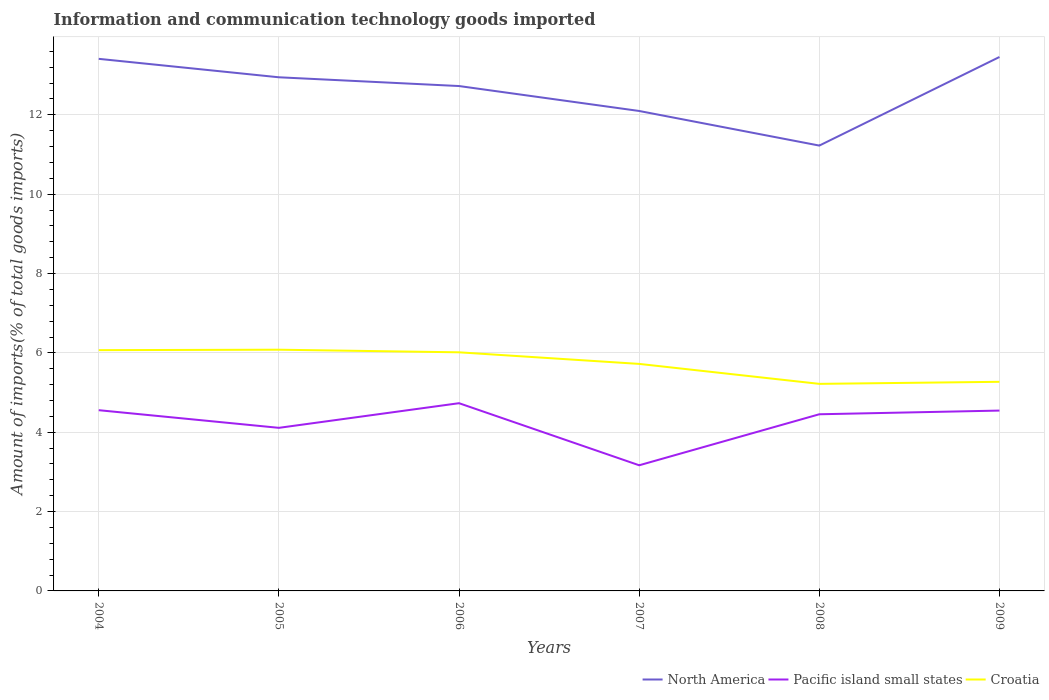How many different coloured lines are there?
Give a very brief answer. 3. Does the line corresponding to Croatia intersect with the line corresponding to North America?
Your response must be concise. No. Across all years, what is the maximum amount of goods imported in Pacific island small states?
Provide a succinct answer. 3.17. What is the total amount of goods imported in North America in the graph?
Your answer should be very brief. 1.31. What is the difference between the highest and the second highest amount of goods imported in Pacific island small states?
Make the answer very short. 1.57. What is the difference between the highest and the lowest amount of goods imported in Pacific island small states?
Offer a terse response. 4. Is the amount of goods imported in North America strictly greater than the amount of goods imported in Pacific island small states over the years?
Give a very brief answer. No. How many years are there in the graph?
Ensure brevity in your answer.  6. Does the graph contain any zero values?
Provide a succinct answer. No. Does the graph contain grids?
Ensure brevity in your answer.  Yes. What is the title of the graph?
Make the answer very short. Information and communication technology goods imported. What is the label or title of the Y-axis?
Keep it short and to the point. Amount of imports(% of total goods imports). What is the Amount of imports(% of total goods imports) in North America in 2004?
Provide a short and direct response. 13.41. What is the Amount of imports(% of total goods imports) of Pacific island small states in 2004?
Provide a short and direct response. 4.56. What is the Amount of imports(% of total goods imports) of Croatia in 2004?
Your response must be concise. 6.07. What is the Amount of imports(% of total goods imports) in North America in 2005?
Offer a very short reply. 12.95. What is the Amount of imports(% of total goods imports) of Pacific island small states in 2005?
Your answer should be compact. 4.11. What is the Amount of imports(% of total goods imports) in Croatia in 2005?
Your answer should be very brief. 6.08. What is the Amount of imports(% of total goods imports) of North America in 2006?
Your answer should be very brief. 12.73. What is the Amount of imports(% of total goods imports) in Pacific island small states in 2006?
Your response must be concise. 4.73. What is the Amount of imports(% of total goods imports) of Croatia in 2006?
Keep it short and to the point. 6.01. What is the Amount of imports(% of total goods imports) in North America in 2007?
Your answer should be very brief. 12.1. What is the Amount of imports(% of total goods imports) in Pacific island small states in 2007?
Your answer should be compact. 3.17. What is the Amount of imports(% of total goods imports) of Croatia in 2007?
Keep it short and to the point. 5.72. What is the Amount of imports(% of total goods imports) of North America in 2008?
Your response must be concise. 11.23. What is the Amount of imports(% of total goods imports) of Pacific island small states in 2008?
Ensure brevity in your answer.  4.45. What is the Amount of imports(% of total goods imports) of Croatia in 2008?
Your answer should be very brief. 5.22. What is the Amount of imports(% of total goods imports) in North America in 2009?
Ensure brevity in your answer.  13.46. What is the Amount of imports(% of total goods imports) of Pacific island small states in 2009?
Your answer should be compact. 4.55. What is the Amount of imports(% of total goods imports) of Croatia in 2009?
Make the answer very short. 5.27. Across all years, what is the maximum Amount of imports(% of total goods imports) of North America?
Your response must be concise. 13.46. Across all years, what is the maximum Amount of imports(% of total goods imports) of Pacific island small states?
Make the answer very short. 4.73. Across all years, what is the maximum Amount of imports(% of total goods imports) of Croatia?
Keep it short and to the point. 6.08. Across all years, what is the minimum Amount of imports(% of total goods imports) in North America?
Offer a terse response. 11.23. Across all years, what is the minimum Amount of imports(% of total goods imports) in Pacific island small states?
Provide a succinct answer. 3.17. Across all years, what is the minimum Amount of imports(% of total goods imports) in Croatia?
Your response must be concise. 5.22. What is the total Amount of imports(% of total goods imports) in North America in the graph?
Your answer should be very brief. 75.87. What is the total Amount of imports(% of total goods imports) of Pacific island small states in the graph?
Make the answer very short. 25.56. What is the total Amount of imports(% of total goods imports) in Croatia in the graph?
Give a very brief answer. 34.38. What is the difference between the Amount of imports(% of total goods imports) of North America in 2004 and that in 2005?
Keep it short and to the point. 0.46. What is the difference between the Amount of imports(% of total goods imports) of Pacific island small states in 2004 and that in 2005?
Give a very brief answer. 0.44. What is the difference between the Amount of imports(% of total goods imports) of Croatia in 2004 and that in 2005?
Give a very brief answer. -0.01. What is the difference between the Amount of imports(% of total goods imports) in North America in 2004 and that in 2006?
Your answer should be very brief. 0.69. What is the difference between the Amount of imports(% of total goods imports) of Pacific island small states in 2004 and that in 2006?
Make the answer very short. -0.18. What is the difference between the Amount of imports(% of total goods imports) in Croatia in 2004 and that in 2006?
Your answer should be very brief. 0.05. What is the difference between the Amount of imports(% of total goods imports) of North America in 2004 and that in 2007?
Your answer should be very brief. 1.31. What is the difference between the Amount of imports(% of total goods imports) in Pacific island small states in 2004 and that in 2007?
Keep it short and to the point. 1.39. What is the difference between the Amount of imports(% of total goods imports) of Croatia in 2004 and that in 2007?
Offer a terse response. 0.35. What is the difference between the Amount of imports(% of total goods imports) in North America in 2004 and that in 2008?
Your answer should be very brief. 2.19. What is the difference between the Amount of imports(% of total goods imports) in Pacific island small states in 2004 and that in 2008?
Offer a terse response. 0.1. What is the difference between the Amount of imports(% of total goods imports) in Croatia in 2004 and that in 2008?
Your answer should be very brief. 0.85. What is the difference between the Amount of imports(% of total goods imports) of North America in 2004 and that in 2009?
Offer a very short reply. -0.05. What is the difference between the Amount of imports(% of total goods imports) in Pacific island small states in 2004 and that in 2009?
Ensure brevity in your answer.  0.01. What is the difference between the Amount of imports(% of total goods imports) in Croatia in 2004 and that in 2009?
Make the answer very short. 0.8. What is the difference between the Amount of imports(% of total goods imports) in North America in 2005 and that in 2006?
Ensure brevity in your answer.  0.22. What is the difference between the Amount of imports(% of total goods imports) in Pacific island small states in 2005 and that in 2006?
Your answer should be very brief. -0.62. What is the difference between the Amount of imports(% of total goods imports) in Croatia in 2005 and that in 2006?
Give a very brief answer. 0.07. What is the difference between the Amount of imports(% of total goods imports) in North America in 2005 and that in 2007?
Your answer should be compact. 0.85. What is the difference between the Amount of imports(% of total goods imports) in Pacific island small states in 2005 and that in 2007?
Keep it short and to the point. 0.94. What is the difference between the Amount of imports(% of total goods imports) of Croatia in 2005 and that in 2007?
Your answer should be compact. 0.36. What is the difference between the Amount of imports(% of total goods imports) in North America in 2005 and that in 2008?
Provide a short and direct response. 1.72. What is the difference between the Amount of imports(% of total goods imports) of Pacific island small states in 2005 and that in 2008?
Provide a succinct answer. -0.34. What is the difference between the Amount of imports(% of total goods imports) of Croatia in 2005 and that in 2008?
Provide a succinct answer. 0.86. What is the difference between the Amount of imports(% of total goods imports) in North America in 2005 and that in 2009?
Ensure brevity in your answer.  -0.51. What is the difference between the Amount of imports(% of total goods imports) in Pacific island small states in 2005 and that in 2009?
Provide a succinct answer. -0.43. What is the difference between the Amount of imports(% of total goods imports) in Croatia in 2005 and that in 2009?
Keep it short and to the point. 0.81. What is the difference between the Amount of imports(% of total goods imports) in North America in 2006 and that in 2007?
Ensure brevity in your answer.  0.63. What is the difference between the Amount of imports(% of total goods imports) of Pacific island small states in 2006 and that in 2007?
Give a very brief answer. 1.57. What is the difference between the Amount of imports(% of total goods imports) in Croatia in 2006 and that in 2007?
Ensure brevity in your answer.  0.29. What is the difference between the Amount of imports(% of total goods imports) of North America in 2006 and that in 2008?
Your answer should be compact. 1.5. What is the difference between the Amount of imports(% of total goods imports) of Pacific island small states in 2006 and that in 2008?
Give a very brief answer. 0.28. What is the difference between the Amount of imports(% of total goods imports) in Croatia in 2006 and that in 2008?
Ensure brevity in your answer.  0.8. What is the difference between the Amount of imports(% of total goods imports) in North America in 2006 and that in 2009?
Offer a terse response. -0.73. What is the difference between the Amount of imports(% of total goods imports) in Pacific island small states in 2006 and that in 2009?
Ensure brevity in your answer.  0.19. What is the difference between the Amount of imports(% of total goods imports) in Croatia in 2006 and that in 2009?
Your answer should be very brief. 0.74. What is the difference between the Amount of imports(% of total goods imports) in North America in 2007 and that in 2008?
Your answer should be compact. 0.87. What is the difference between the Amount of imports(% of total goods imports) in Pacific island small states in 2007 and that in 2008?
Your answer should be very brief. -1.29. What is the difference between the Amount of imports(% of total goods imports) in Croatia in 2007 and that in 2008?
Provide a short and direct response. 0.5. What is the difference between the Amount of imports(% of total goods imports) of North America in 2007 and that in 2009?
Your answer should be compact. -1.36. What is the difference between the Amount of imports(% of total goods imports) of Pacific island small states in 2007 and that in 2009?
Offer a terse response. -1.38. What is the difference between the Amount of imports(% of total goods imports) in Croatia in 2007 and that in 2009?
Your answer should be compact. 0.45. What is the difference between the Amount of imports(% of total goods imports) in North America in 2008 and that in 2009?
Offer a terse response. -2.23. What is the difference between the Amount of imports(% of total goods imports) in Pacific island small states in 2008 and that in 2009?
Your response must be concise. -0.09. What is the difference between the Amount of imports(% of total goods imports) of Croatia in 2008 and that in 2009?
Offer a very short reply. -0.05. What is the difference between the Amount of imports(% of total goods imports) in North America in 2004 and the Amount of imports(% of total goods imports) in Pacific island small states in 2005?
Ensure brevity in your answer.  9.3. What is the difference between the Amount of imports(% of total goods imports) of North America in 2004 and the Amount of imports(% of total goods imports) of Croatia in 2005?
Make the answer very short. 7.33. What is the difference between the Amount of imports(% of total goods imports) in Pacific island small states in 2004 and the Amount of imports(% of total goods imports) in Croatia in 2005?
Provide a succinct answer. -1.52. What is the difference between the Amount of imports(% of total goods imports) of North America in 2004 and the Amount of imports(% of total goods imports) of Pacific island small states in 2006?
Ensure brevity in your answer.  8.68. What is the difference between the Amount of imports(% of total goods imports) in North America in 2004 and the Amount of imports(% of total goods imports) in Croatia in 2006?
Your answer should be compact. 7.4. What is the difference between the Amount of imports(% of total goods imports) in Pacific island small states in 2004 and the Amount of imports(% of total goods imports) in Croatia in 2006?
Make the answer very short. -1.46. What is the difference between the Amount of imports(% of total goods imports) in North America in 2004 and the Amount of imports(% of total goods imports) in Pacific island small states in 2007?
Offer a terse response. 10.24. What is the difference between the Amount of imports(% of total goods imports) of North America in 2004 and the Amount of imports(% of total goods imports) of Croatia in 2007?
Your response must be concise. 7.69. What is the difference between the Amount of imports(% of total goods imports) of Pacific island small states in 2004 and the Amount of imports(% of total goods imports) of Croatia in 2007?
Your response must be concise. -1.17. What is the difference between the Amount of imports(% of total goods imports) in North America in 2004 and the Amount of imports(% of total goods imports) in Pacific island small states in 2008?
Offer a terse response. 8.96. What is the difference between the Amount of imports(% of total goods imports) of North America in 2004 and the Amount of imports(% of total goods imports) of Croatia in 2008?
Give a very brief answer. 8.19. What is the difference between the Amount of imports(% of total goods imports) of Pacific island small states in 2004 and the Amount of imports(% of total goods imports) of Croatia in 2008?
Your answer should be compact. -0.66. What is the difference between the Amount of imports(% of total goods imports) of North America in 2004 and the Amount of imports(% of total goods imports) of Pacific island small states in 2009?
Give a very brief answer. 8.87. What is the difference between the Amount of imports(% of total goods imports) of North America in 2004 and the Amount of imports(% of total goods imports) of Croatia in 2009?
Ensure brevity in your answer.  8.14. What is the difference between the Amount of imports(% of total goods imports) of Pacific island small states in 2004 and the Amount of imports(% of total goods imports) of Croatia in 2009?
Your answer should be very brief. -0.72. What is the difference between the Amount of imports(% of total goods imports) in North America in 2005 and the Amount of imports(% of total goods imports) in Pacific island small states in 2006?
Your answer should be compact. 8.21. What is the difference between the Amount of imports(% of total goods imports) of North America in 2005 and the Amount of imports(% of total goods imports) of Croatia in 2006?
Offer a very short reply. 6.93. What is the difference between the Amount of imports(% of total goods imports) in Pacific island small states in 2005 and the Amount of imports(% of total goods imports) in Croatia in 2006?
Provide a short and direct response. -1.9. What is the difference between the Amount of imports(% of total goods imports) of North America in 2005 and the Amount of imports(% of total goods imports) of Pacific island small states in 2007?
Your response must be concise. 9.78. What is the difference between the Amount of imports(% of total goods imports) in North America in 2005 and the Amount of imports(% of total goods imports) in Croatia in 2007?
Your answer should be compact. 7.22. What is the difference between the Amount of imports(% of total goods imports) of Pacific island small states in 2005 and the Amount of imports(% of total goods imports) of Croatia in 2007?
Your answer should be very brief. -1.61. What is the difference between the Amount of imports(% of total goods imports) in North America in 2005 and the Amount of imports(% of total goods imports) in Pacific island small states in 2008?
Your answer should be compact. 8.49. What is the difference between the Amount of imports(% of total goods imports) in North America in 2005 and the Amount of imports(% of total goods imports) in Croatia in 2008?
Give a very brief answer. 7.73. What is the difference between the Amount of imports(% of total goods imports) of Pacific island small states in 2005 and the Amount of imports(% of total goods imports) of Croatia in 2008?
Provide a succinct answer. -1.11. What is the difference between the Amount of imports(% of total goods imports) of North America in 2005 and the Amount of imports(% of total goods imports) of Pacific island small states in 2009?
Offer a very short reply. 8.4. What is the difference between the Amount of imports(% of total goods imports) in North America in 2005 and the Amount of imports(% of total goods imports) in Croatia in 2009?
Make the answer very short. 7.68. What is the difference between the Amount of imports(% of total goods imports) of Pacific island small states in 2005 and the Amount of imports(% of total goods imports) of Croatia in 2009?
Offer a terse response. -1.16. What is the difference between the Amount of imports(% of total goods imports) in North America in 2006 and the Amount of imports(% of total goods imports) in Pacific island small states in 2007?
Your response must be concise. 9.56. What is the difference between the Amount of imports(% of total goods imports) in North America in 2006 and the Amount of imports(% of total goods imports) in Croatia in 2007?
Provide a succinct answer. 7. What is the difference between the Amount of imports(% of total goods imports) in Pacific island small states in 2006 and the Amount of imports(% of total goods imports) in Croatia in 2007?
Provide a succinct answer. -0.99. What is the difference between the Amount of imports(% of total goods imports) in North America in 2006 and the Amount of imports(% of total goods imports) in Pacific island small states in 2008?
Your answer should be very brief. 8.27. What is the difference between the Amount of imports(% of total goods imports) in North America in 2006 and the Amount of imports(% of total goods imports) in Croatia in 2008?
Give a very brief answer. 7.51. What is the difference between the Amount of imports(% of total goods imports) of Pacific island small states in 2006 and the Amount of imports(% of total goods imports) of Croatia in 2008?
Offer a very short reply. -0.49. What is the difference between the Amount of imports(% of total goods imports) of North America in 2006 and the Amount of imports(% of total goods imports) of Pacific island small states in 2009?
Offer a very short reply. 8.18. What is the difference between the Amount of imports(% of total goods imports) in North America in 2006 and the Amount of imports(% of total goods imports) in Croatia in 2009?
Offer a very short reply. 7.46. What is the difference between the Amount of imports(% of total goods imports) of Pacific island small states in 2006 and the Amount of imports(% of total goods imports) of Croatia in 2009?
Offer a very short reply. -0.54. What is the difference between the Amount of imports(% of total goods imports) of North America in 2007 and the Amount of imports(% of total goods imports) of Pacific island small states in 2008?
Provide a succinct answer. 7.64. What is the difference between the Amount of imports(% of total goods imports) in North America in 2007 and the Amount of imports(% of total goods imports) in Croatia in 2008?
Keep it short and to the point. 6.88. What is the difference between the Amount of imports(% of total goods imports) of Pacific island small states in 2007 and the Amount of imports(% of total goods imports) of Croatia in 2008?
Ensure brevity in your answer.  -2.05. What is the difference between the Amount of imports(% of total goods imports) of North America in 2007 and the Amount of imports(% of total goods imports) of Pacific island small states in 2009?
Provide a short and direct response. 7.55. What is the difference between the Amount of imports(% of total goods imports) in North America in 2007 and the Amount of imports(% of total goods imports) in Croatia in 2009?
Offer a terse response. 6.83. What is the difference between the Amount of imports(% of total goods imports) in Pacific island small states in 2007 and the Amount of imports(% of total goods imports) in Croatia in 2009?
Give a very brief answer. -2.1. What is the difference between the Amount of imports(% of total goods imports) of North America in 2008 and the Amount of imports(% of total goods imports) of Pacific island small states in 2009?
Keep it short and to the point. 6.68. What is the difference between the Amount of imports(% of total goods imports) in North America in 2008 and the Amount of imports(% of total goods imports) in Croatia in 2009?
Offer a very short reply. 5.95. What is the difference between the Amount of imports(% of total goods imports) of Pacific island small states in 2008 and the Amount of imports(% of total goods imports) of Croatia in 2009?
Your answer should be compact. -0.82. What is the average Amount of imports(% of total goods imports) of North America per year?
Provide a short and direct response. 12.64. What is the average Amount of imports(% of total goods imports) of Pacific island small states per year?
Give a very brief answer. 4.26. What is the average Amount of imports(% of total goods imports) in Croatia per year?
Offer a very short reply. 5.73. In the year 2004, what is the difference between the Amount of imports(% of total goods imports) in North America and Amount of imports(% of total goods imports) in Pacific island small states?
Provide a succinct answer. 8.86. In the year 2004, what is the difference between the Amount of imports(% of total goods imports) in North America and Amount of imports(% of total goods imports) in Croatia?
Provide a short and direct response. 7.34. In the year 2004, what is the difference between the Amount of imports(% of total goods imports) in Pacific island small states and Amount of imports(% of total goods imports) in Croatia?
Keep it short and to the point. -1.51. In the year 2005, what is the difference between the Amount of imports(% of total goods imports) in North America and Amount of imports(% of total goods imports) in Pacific island small states?
Your answer should be very brief. 8.84. In the year 2005, what is the difference between the Amount of imports(% of total goods imports) in North America and Amount of imports(% of total goods imports) in Croatia?
Make the answer very short. 6.87. In the year 2005, what is the difference between the Amount of imports(% of total goods imports) in Pacific island small states and Amount of imports(% of total goods imports) in Croatia?
Provide a succinct answer. -1.97. In the year 2006, what is the difference between the Amount of imports(% of total goods imports) of North America and Amount of imports(% of total goods imports) of Pacific island small states?
Provide a short and direct response. 7.99. In the year 2006, what is the difference between the Amount of imports(% of total goods imports) of North America and Amount of imports(% of total goods imports) of Croatia?
Offer a very short reply. 6.71. In the year 2006, what is the difference between the Amount of imports(% of total goods imports) of Pacific island small states and Amount of imports(% of total goods imports) of Croatia?
Provide a succinct answer. -1.28. In the year 2007, what is the difference between the Amount of imports(% of total goods imports) in North America and Amount of imports(% of total goods imports) in Pacific island small states?
Your answer should be very brief. 8.93. In the year 2007, what is the difference between the Amount of imports(% of total goods imports) in North America and Amount of imports(% of total goods imports) in Croatia?
Offer a very short reply. 6.38. In the year 2007, what is the difference between the Amount of imports(% of total goods imports) in Pacific island small states and Amount of imports(% of total goods imports) in Croatia?
Keep it short and to the point. -2.56. In the year 2008, what is the difference between the Amount of imports(% of total goods imports) of North America and Amount of imports(% of total goods imports) of Pacific island small states?
Keep it short and to the point. 6.77. In the year 2008, what is the difference between the Amount of imports(% of total goods imports) of North America and Amount of imports(% of total goods imports) of Croatia?
Provide a short and direct response. 6.01. In the year 2008, what is the difference between the Amount of imports(% of total goods imports) of Pacific island small states and Amount of imports(% of total goods imports) of Croatia?
Your answer should be compact. -0.77. In the year 2009, what is the difference between the Amount of imports(% of total goods imports) in North America and Amount of imports(% of total goods imports) in Pacific island small states?
Ensure brevity in your answer.  8.91. In the year 2009, what is the difference between the Amount of imports(% of total goods imports) in North America and Amount of imports(% of total goods imports) in Croatia?
Make the answer very short. 8.19. In the year 2009, what is the difference between the Amount of imports(% of total goods imports) in Pacific island small states and Amount of imports(% of total goods imports) in Croatia?
Offer a very short reply. -0.73. What is the ratio of the Amount of imports(% of total goods imports) of North America in 2004 to that in 2005?
Give a very brief answer. 1.04. What is the ratio of the Amount of imports(% of total goods imports) of Pacific island small states in 2004 to that in 2005?
Make the answer very short. 1.11. What is the ratio of the Amount of imports(% of total goods imports) of Croatia in 2004 to that in 2005?
Make the answer very short. 1. What is the ratio of the Amount of imports(% of total goods imports) in North America in 2004 to that in 2006?
Provide a succinct answer. 1.05. What is the ratio of the Amount of imports(% of total goods imports) of Pacific island small states in 2004 to that in 2006?
Your response must be concise. 0.96. What is the ratio of the Amount of imports(% of total goods imports) in Croatia in 2004 to that in 2006?
Give a very brief answer. 1.01. What is the ratio of the Amount of imports(% of total goods imports) in North America in 2004 to that in 2007?
Your response must be concise. 1.11. What is the ratio of the Amount of imports(% of total goods imports) of Pacific island small states in 2004 to that in 2007?
Make the answer very short. 1.44. What is the ratio of the Amount of imports(% of total goods imports) of Croatia in 2004 to that in 2007?
Offer a terse response. 1.06. What is the ratio of the Amount of imports(% of total goods imports) of North America in 2004 to that in 2008?
Make the answer very short. 1.19. What is the ratio of the Amount of imports(% of total goods imports) in Pacific island small states in 2004 to that in 2008?
Ensure brevity in your answer.  1.02. What is the ratio of the Amount of imports(% of total goods imports) of Croatia in 2004 to that in 2008?
Your response must be concise. 1.16. What is the ratio of the Amount of imports(% of total goods imports) in North America in 2004 to that in 2009?
Give a very brief answer. 1. What is the ratio of the Amount of imports(% of total goods imports) of Croatia in 2004 to that in 2009?
Give a very brief answer. 1.15. What is the ratio of the Amount of imports(% of total goods imports) of North America in 2005 to that in 2006?
Ensure brevity in your answer.  1.02. What is the ratio of the Amount of imports(% of total goods imports) in Pacific island small states in 2005 to that in 2006?
Your answer should be compact. 0.87. What is the ratio of the Amount of imports(% of total goods imports) of Croatia in 2005 to that in 2006?
Your answer should be very brief. 1.01. What is the ratio of the Amount of imports(% of total goods imports) of North America in 2005 to that in 2007?
Give a very brief answer. 1.07. What is the ratio of the Amount of imports(% of total goods imports) of Pacific island small states in 2005 to that in 2007?
Your response must be concise. 1.3. What is the ratio of the Amount of imports(% of total goods imports) in Croatia in 2005 to that in 2007?
Make the answer very short. 1.06. What is the ratio of the Amount of imports(% of total goods imports) in North America in 2005 to that in 2008?
Offer a terse response. 1.15. What is the ratio of the Amount of imports(% of total goods imports) in Pacific island small states in 2005 to that in 2008?
Keep it short and to the point. 0.92. What is the ratio of the Amount of imports(% of total goods imports) in Croatia in 2005 to that in 2008?
Your answer should be very brief. 1.17. What is the ratio of the Amount of imports(% of total goods imports) of North America in 2005 to that in 2009?
Provide a succinct answer. 0.96. What is the ratio of the Amount of imports(% of total goods imports) of Pacific island small states in 2005 to that in 2009?
Provide a short and direct response. 0.9. What is the ratio of the Amount of imports(% of total goods imports) of Croatia in 2005 to that in 2009?
Provide a short and direct response. 1.15. What is the ratio of the Amount of imports(% of total goods imports) in North America in 2006 to that in 2007?
Your response must be concise. 1.05. What is the ratio of the Amount of imports(% of total goods imports) in Pacific island small states in 2006 to that in 2007?
Make the answer very short. 1.49. What is the ratio of the Amount of imports(% of total goods imports) in Croatia in 2006 to that in 2007?
Ensure brevity in your answer.  1.05. What is the ratio of the Amount of imports(% of total goods imports) of North America in 2006 to that in 2008?
Your answer should be compact. 1.13. What is the ratio of the Amount of imports(% of total goods imports) in Pacific island small states in 2006 to that in 2008?
Your response must be concise. 1.06. What is the ratio of the Amount of imports(% of total goods imports) in Croatia in 2006 to that in 2008?
Ensure brevity in your answer.  1.15. What is the ratio of the Amount of imports(% of total goods imports) in North America in 2006 to that in 2009?
Your answer should be compact. 0.95. What is the ratio of the Amount of imports(% of total goods imports) in Pacific island small states in 2006 to that in 2009?
Your answer should be very brief. 1.04. What is the ratio of the Amount of imports(% of total goods imports) of Croatia in 2006 to that in 2009?
Your answer should be compact. 1.14. What is the ratio of the Amount of imports(% of total goods imports) of North America in 2007 to that in 2008?
Your answer should be compact. 1.08. What is the ratio of the Amount of imports(% of total goods imports) of Pacific island small states in 2007 to that in 2008?
Provide a short and direct response. 0.71. What is the ratio of the Amount of imports(% of total goods imports) of Croatia in 2007 to that in 2008?
Ensure brevity in your answer.  1.1. What is the ratio of the Amount of imports(% of total goods imports) of North America in 2007 to that in 2009?
Your response must be concise. 0.9. What is the ratio of the Amount of imports(% of total goods imports) in Pacific island small states in 2007 to that in 2009?
Provide a short and direct response. 0.7. What is the ratio of the Amount of imports(% of total goods imports) in Croatia in 2007 to that in 2009?
Give a very brief answer. 1.09. What is the ratio of the Amount of imports(% of total goods imports) of North America in 2008 to that in 2009?
Offer a terse response. 0.83. What is the ratio of the Amount of imports(% of total goods imports) in Pacific island small states in 2008 to that in 2009?
Ensure brevity in your answer.  0.98. What is the ratio of the Amount of imports(% of total goods imports) of Croatia in 2008 to that in 2009?
Your answer should be compact. 0.99. What is the difference between the highest and the second highest Amount of imports(% of total goods imports) of North America?
Offer a very short reply. 0.05. What is the difference between the highest and the second highest Amount of imports(% of total goods imports) of Pacific island small states?
Your answer should be compact. 0.18. What is the difference between the highest and the second highest Amount of imports(% of total goods imports) in Croatia?
Offer a terse response. 0.01. What is the difference between the highest and the lowest Amount of imports(% of total goods imports) in North America?
Provide a short and direct response. 2.23. What is the difference between the highest and the lowest Amount of imports(% of total goods imports) of Pacific island small states?
Offer a very short reply. 1.57. What is the difference between the highest and the lowest Amount of imports(% of total goods imports) of Croatia?
Ensure brevity in your answer.  0.86. 